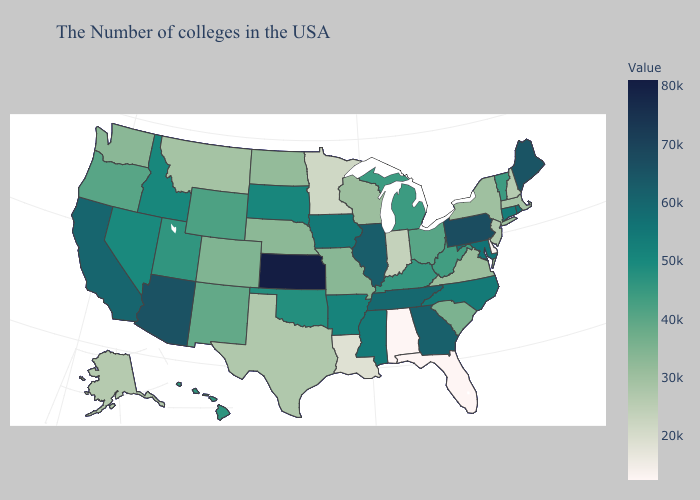Does the map have missing data?
Give a very brief answer. No. Among the states that border Nebraska , which have the lowest value?
Give a very brief answer. Missouri. 